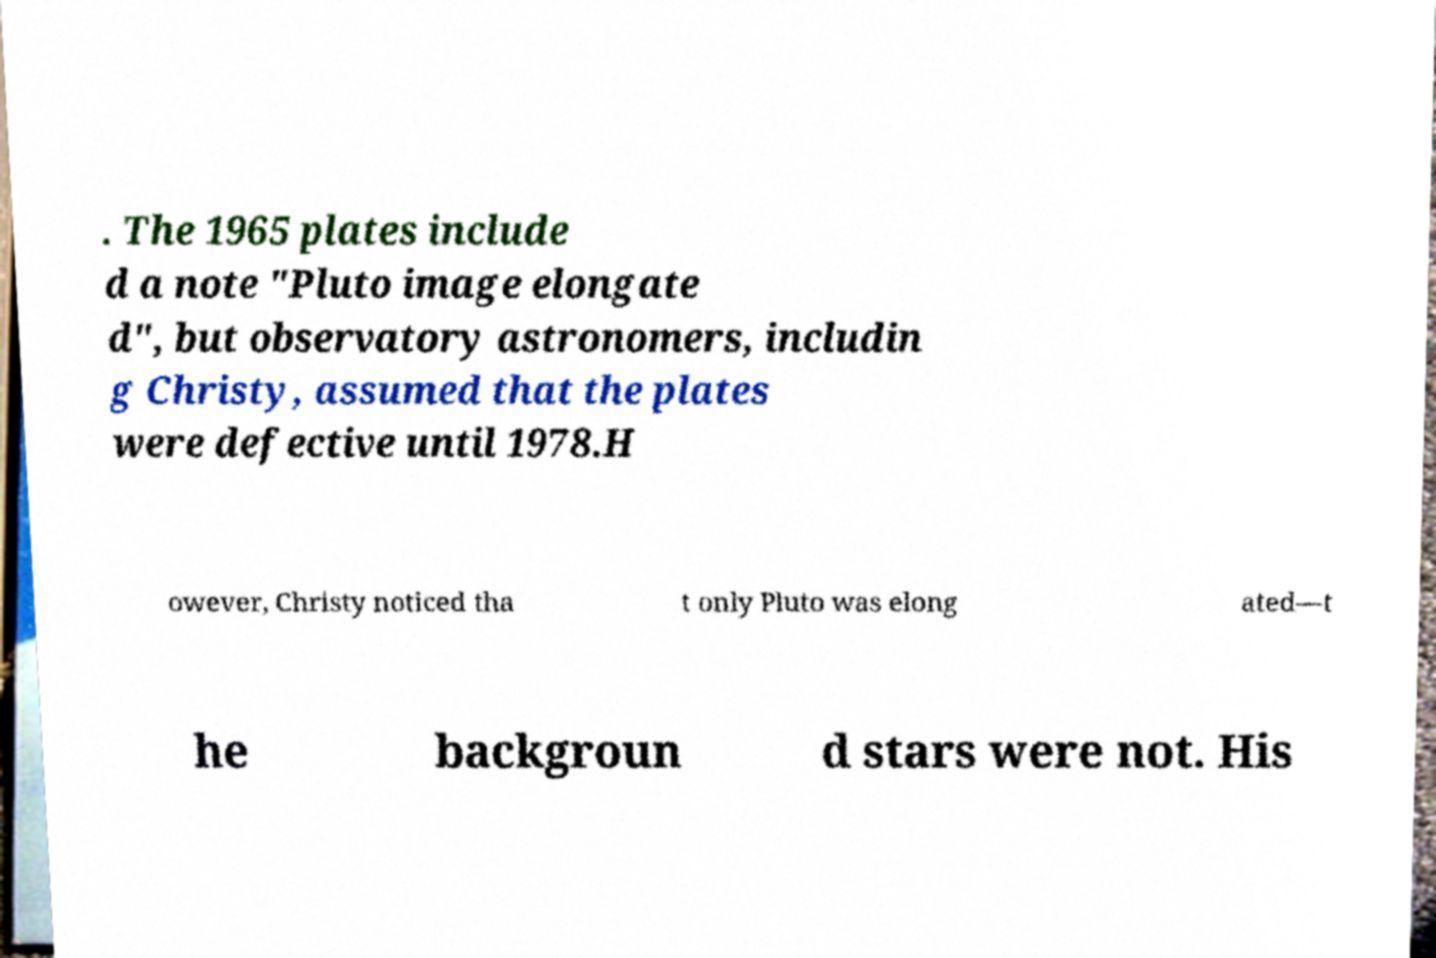Can you accurately transcribe the text from the provided image for me? . The 1965 plates include d a note "Pluto image elongate d", but observatory astronomers, includin g Christy, assumed that the plates were defective until 1978.H owever, Christy noticed tha t only Pluto was elong ated—t he backgroun d stars were not. His 